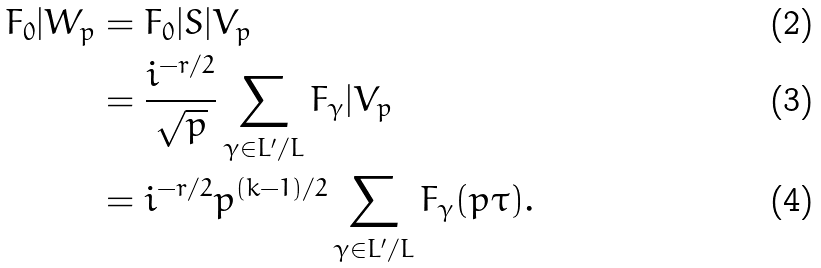<formula> <loc_0><loc_0><loc_500><loc_500>F _ { 0 } | W _ { p } & = F _ { 0 } | S | V _ { p } \\ & = \frac { i ^ { - r / 2 } } { \sqrt { p } } \sum _ { \gamma \in L ^ { \prime } / L } F _ { \gamma } | V _ { p } \\ & = i ^ { - r / 2 } p ^ { ( k - 1 ) / 2 } \sum _ { \gamma \in L ^ { \prime } / L } F _ { \gamma } ( p \tau ) .</formula> 